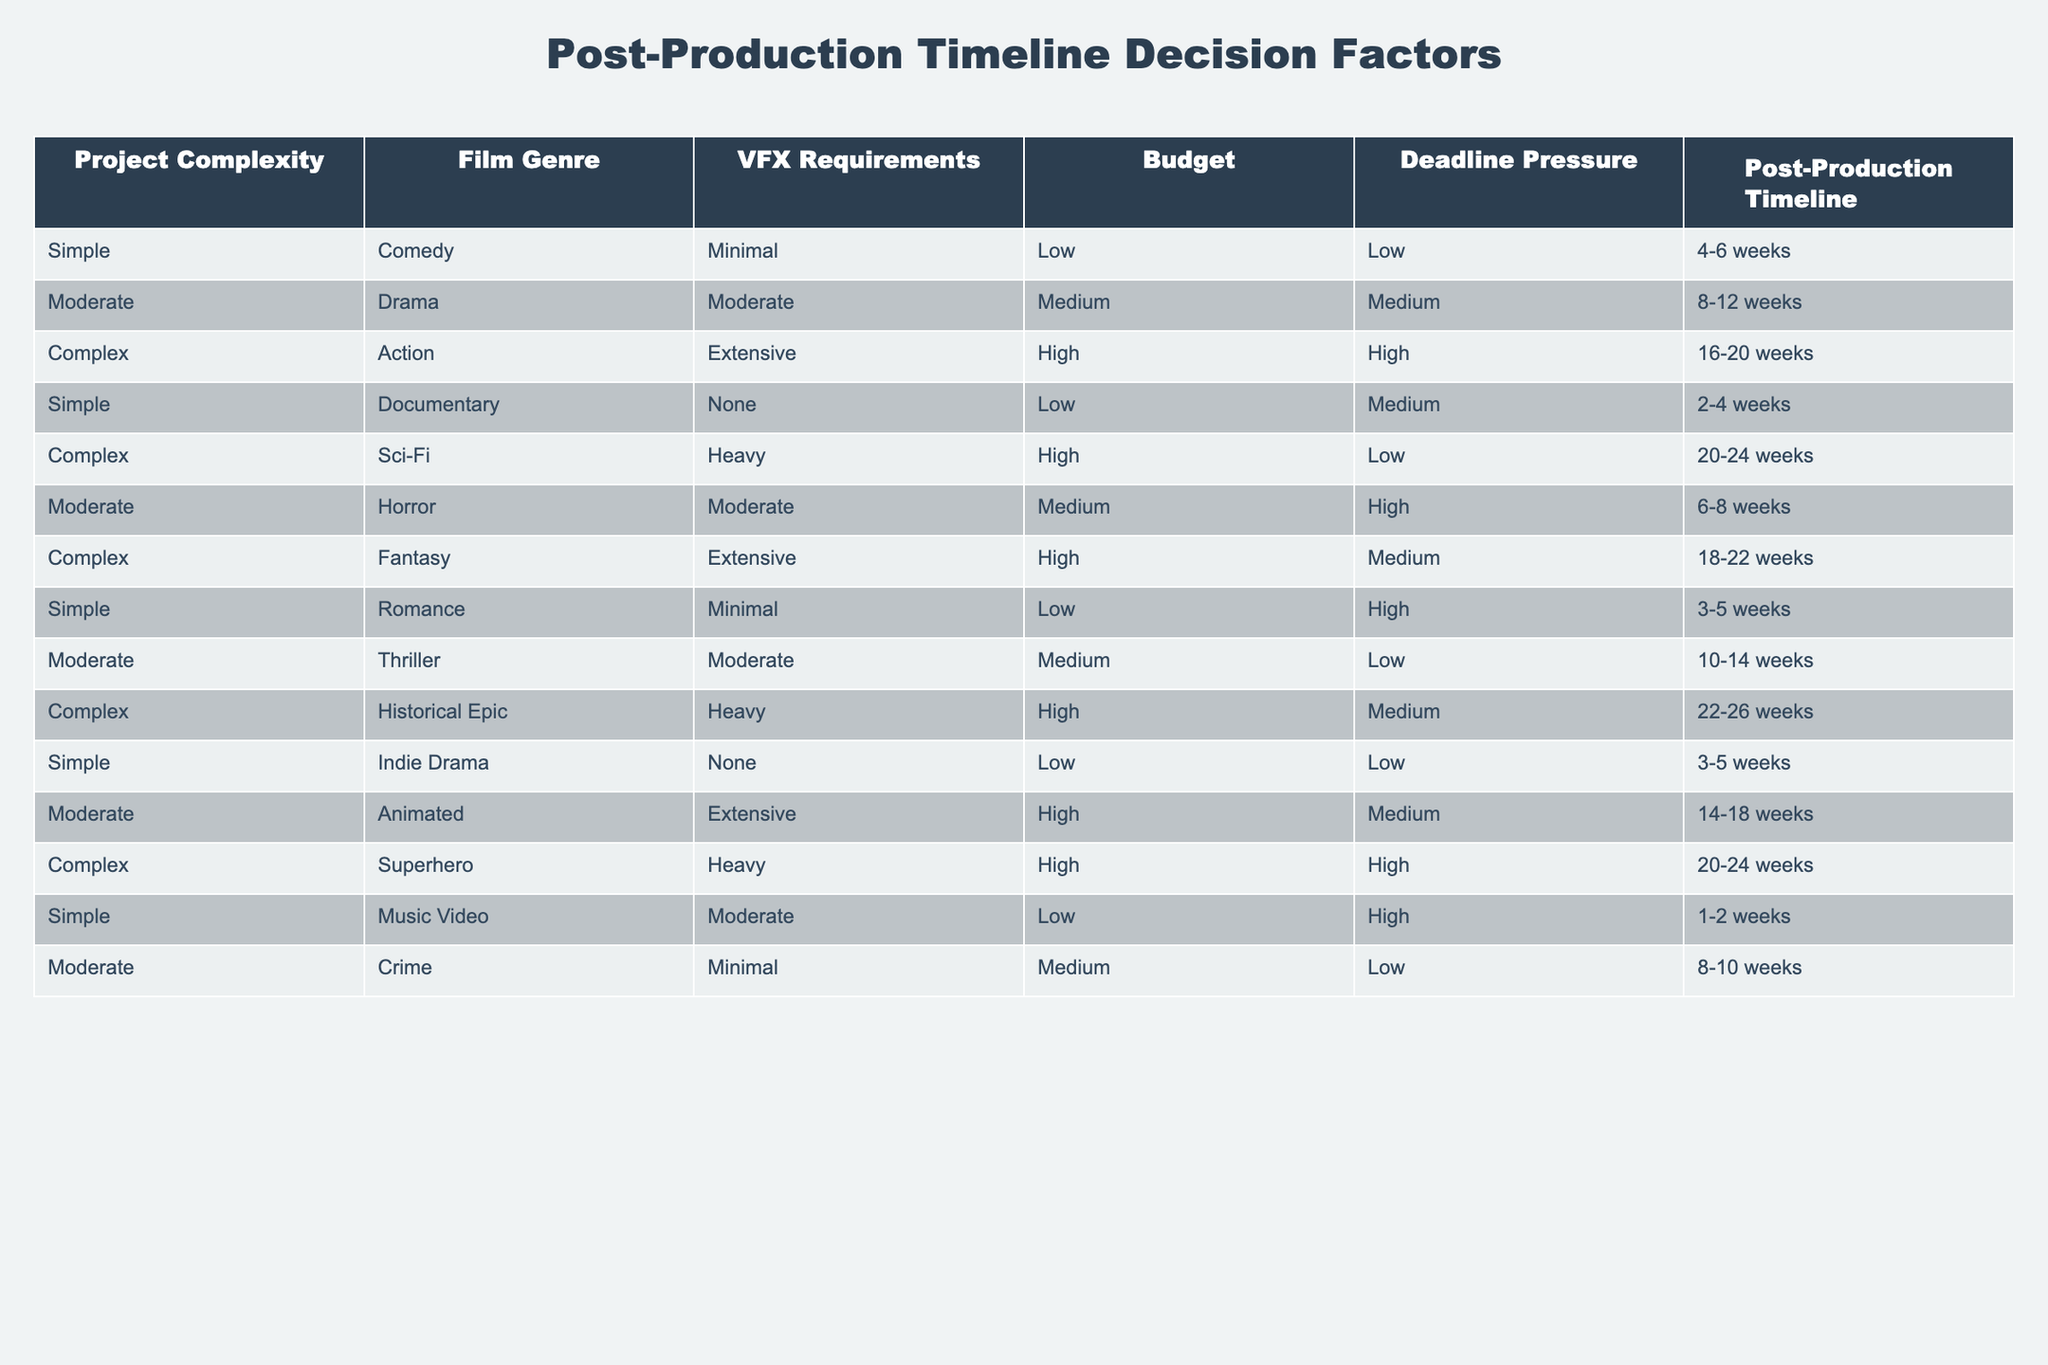What is the post-production timeline for a simple comedy film with minimal VFX requirements? The table lists a simple comedy film with minimal VFX requirements under the 'Post-Production Timeline' column, which indicates that it typically takes 4 to 6 weeks.
Answer: 4-6 weeks How many weeks does a complex historical epic film take in post-production? According to the table, a complex historical epic film is listed with a post-production timeline of 22 to 26 weeks.
Answer: 22-26 weeks Is it true that all complex films require a post-production timeline of at least 16 weeks? By reviewing the table, all entries under the 'Complex' category show timelines of 16 weeks or more (16-20 weeks, 20-24 weeks, 18-22 weeks, and 22-26 weeks), confirming that the statement is true.
Answer: Yes What is the average post-production timeline for moderate films? The moderate films listed are Drama (8-12 weeks), Horror (6-8 weeks), Animated (14-18 weeks), Thriller (10-14 weeks), and Crime (8-10 weeks). Calculating the average involves finding the midpoint for each: Drama (10 weeks), Horror (7 weeks), Animated (16 weeks), Thriller (12 weeks), Crime (9 weeks). Summing them gives 10 + 7 + 16 + 12 + 9 = 54, and dividing by 5 gives an average of 10.8 weeks, which rounds to approximately 11 weeks.
Answer: 11 weeks What is the relationship between VFX requirements and the average post-production timeline? Analyzing the data, films with minimal VFX (such as Comedy and Romance) take shorter times (4-6 weeks and 3-5 weeks), while those with extensive or heavy VFX (like Action or Sci-Fi) take much longer (16-20 weeks and 20-24 weeks). Therefore, there's a clear trend that higher VFX requirements correlate with longer timelines.
Answer: Higher VFX leads to longer timelines 